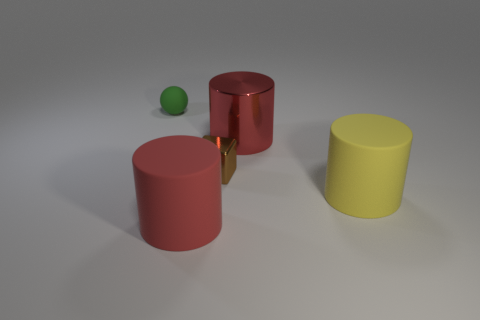Subtract all big rubber cylinders. How many cylinders are left? 1 Add 4 shiny blocks. How many objects exist? 9 Subtract all balls. How many objects are left? 4 Subtract all yellow cylinders. How many cylinders are left? 2 Subtract all cyan cylinders. Subtract all green blocks. How many cylinders are left? 3 Subtract all red cubes. How many yellow balls are left? 0 Subtract all tiny green shiny balls. Subtract all cylinders. How many objects are left? 2 Add 5 matte balls. How many matte balls are left? 6 Add 3 large red matte things. How many large red matte things exist? 4 Subtract 0 green cylinders. How many objects are left? 5 